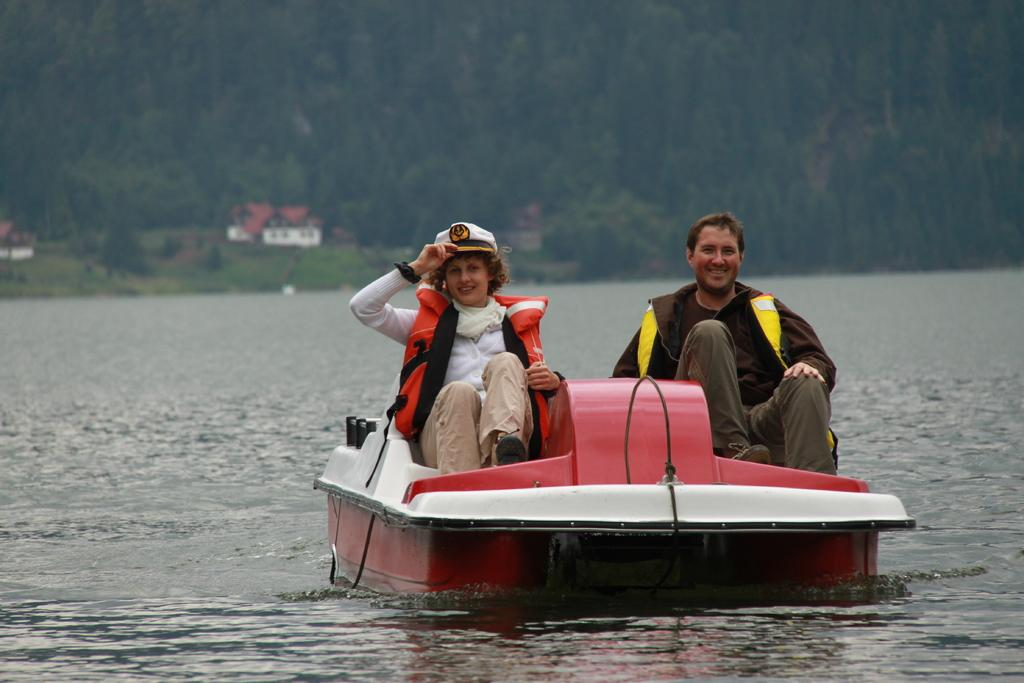What is the main subject of the image? The main subject of the image is water. What is on the water in the image? There is a boat on the water in the image. Who or what is in the boat? People are sitting in the boat. What can be seen in the background of the image? There are trees and sheds in the background of the image. What type of wire can be seen connecting the trees in the image? There is no wire connecting the trees in the image; only trees and sheds are visible in the background. Can you tell me when the birth of the first person in the boat occurred? There is no information about the birth of the people in the boat in the image, nor is there any indication of when it might have occurred. 